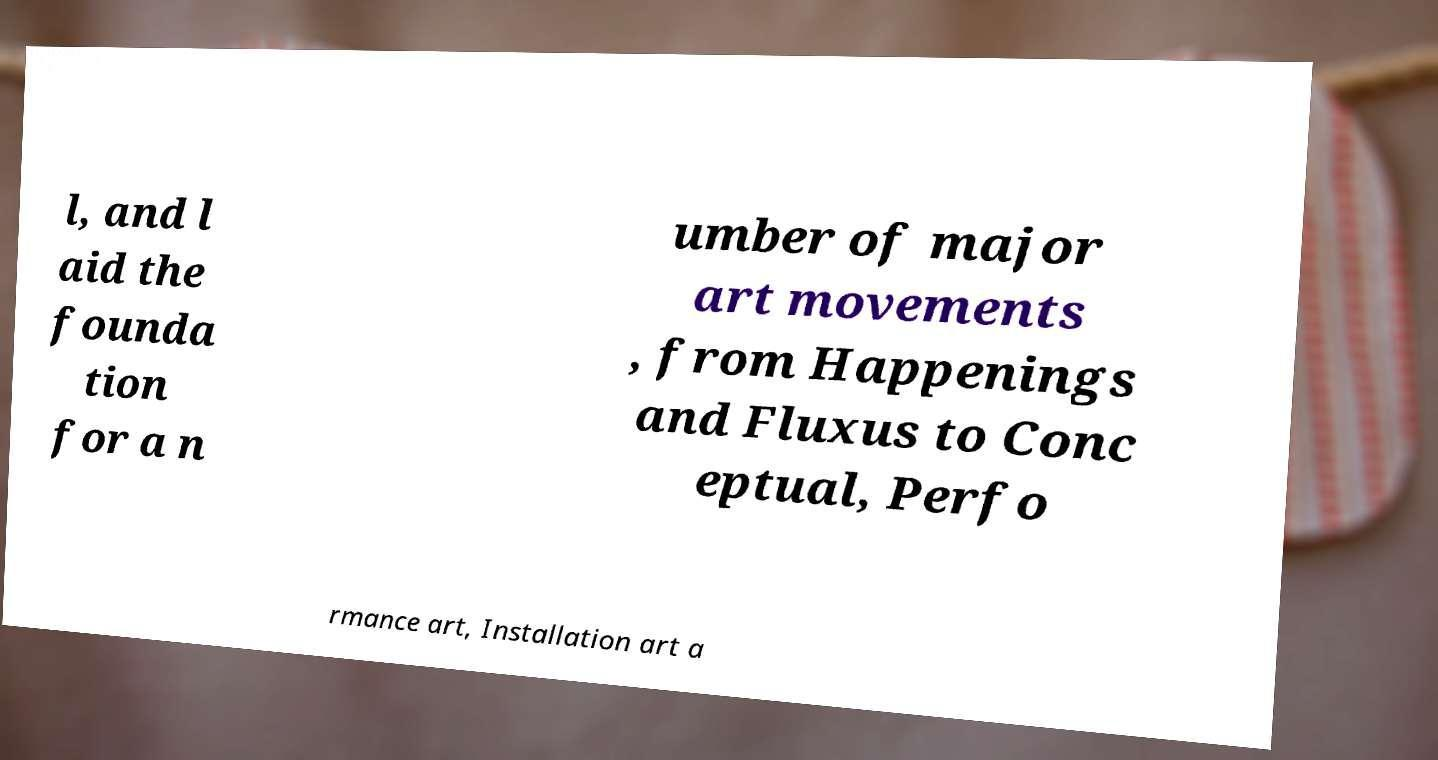For documentation purposes, I need the text within this image transcribed. Could you provide that? l, and l aid the founda tion for a n umber of major art movements , from Happenings and Fluxus to Conc eptual, Perfo rmance art, Installation art a 